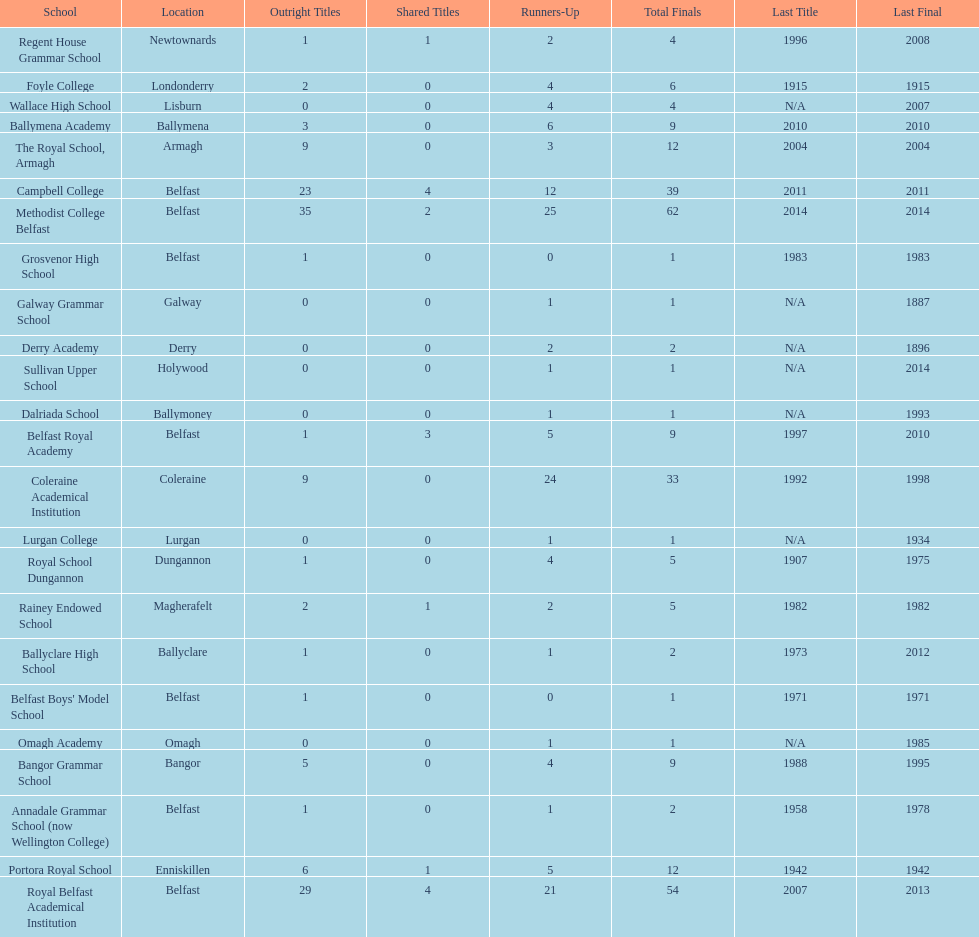What was the last year that the regent house grammar school won a title? 1996. 